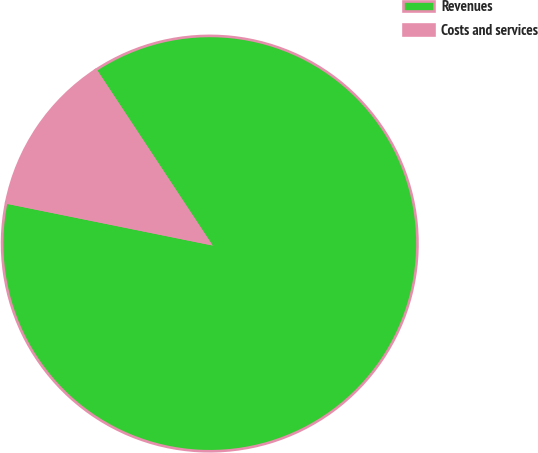Convert chart to OTSL. <chart><loc_0><loc_0><loc_500><loc_500><pie_chart><fcel>Revenues<fcel>Costs and services<nl><fcel>87.45%<fcel>12.55%<nl></chart> 